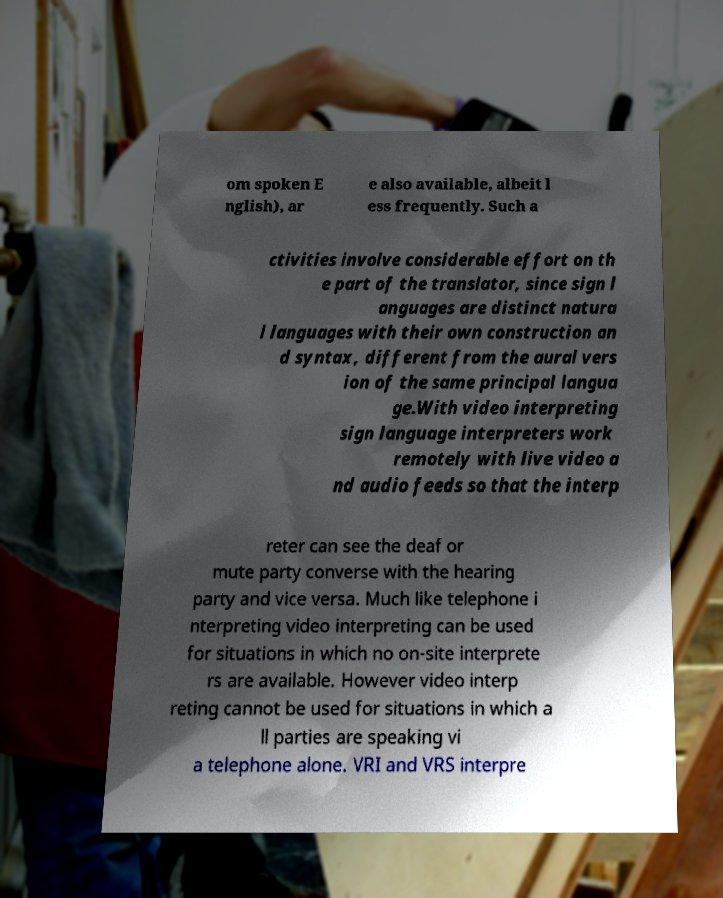There's text embedded in this image that I need extracted. Can you transcribe it verbatim? om spoken E nglish), ar e also available, albeit l ess frequently. Such a ctivities involve considerable effort on th e part of the translator, since sign l anguages are distinct natura l languages with their own construction an d syntax, different from the aural vers ion of the same principal langua ge.With video interpreting sign language interpreters work remotely with live video a nd audio feeds so that the interp reter can see the deaf or mute party converse with the hearing party and vice versa. Much like telephone i nterpreting video interpreting can be used for situations in which no on-site interprete rs are available. However video interp reting cannot be used for situations in which a ll parties are speaking vi a telephone alone. VRI and VRS interpre 